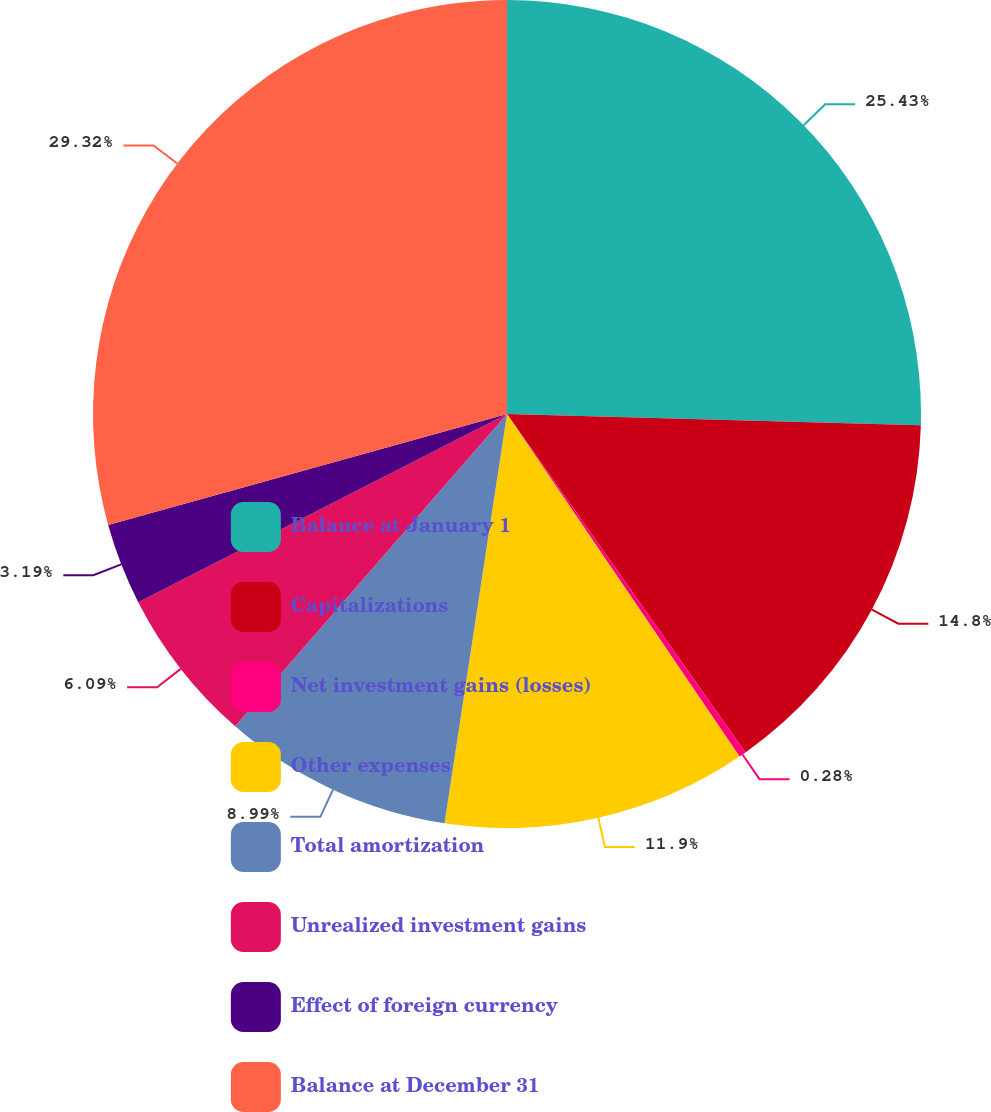<chart> <loc_0><loc_0><loc_500><loc_500><pie_chart><fcel>Balance at January 1<fcel>Capitalizations<fcel>Net investment gains (losses)<fcel>Other expenses<fcel>Total amortization<fcel>Unrealized investment gains<fcel>Effect of foreign currency<fcel>Balance at December 31<nl><fcel>25.43%<fcel>14.8%<fcel>0.28%<fcel>11.9%<fcel>8.99%<fcel>6.09%<fcel>3.19%<fcel>29.32%<nl></chart> 